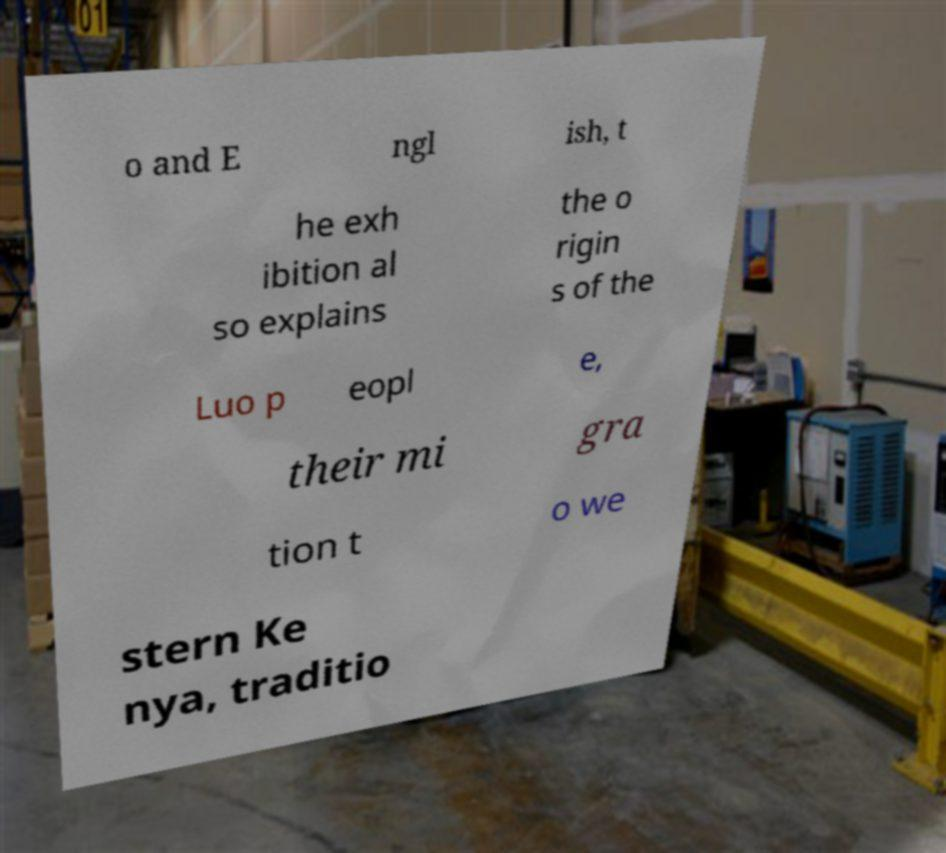Can you read and provide the text displayed in the image?This photo seems to have some interesting text. Can you extract and type it out for me? o and E ngl ish, t he exh ibition al so explains the o rigin s of the Luo p eopl e, their mi gra tion t o we stern Ke nya, traditio 